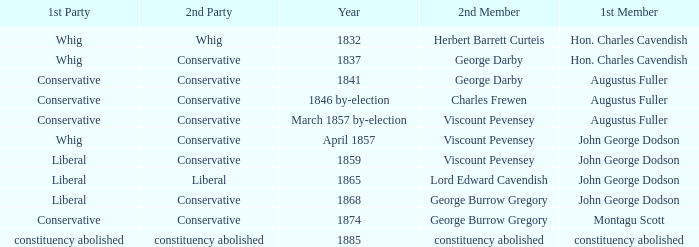In 1865, what was the first party? Liberal. 